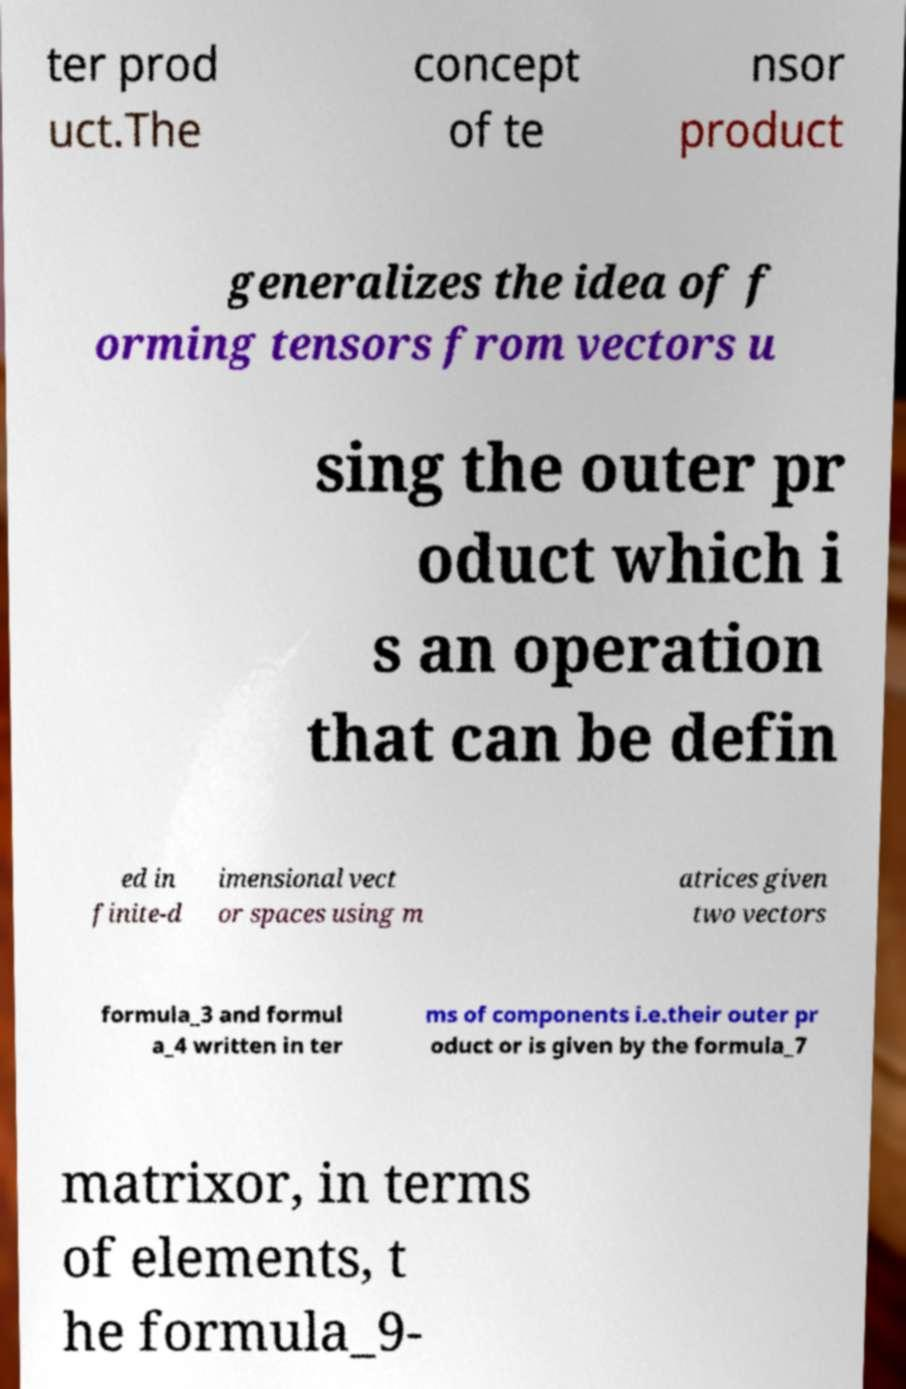Can you accurately transcribe the text from the provided image for me? ter prod uct.The concept of te nsor product generalizes the idea of f orming tensors from vectors u sing the outer pr oduct which i s an operation that can be defin ed in finite-d imensional vect or spaces using m atrices given two vectors formula_3 and formul a_4 written in ter ms of components i.e.their outer pr oduct or is given by the formula_7 matrixor, in terms of elements, t he formula_9- 